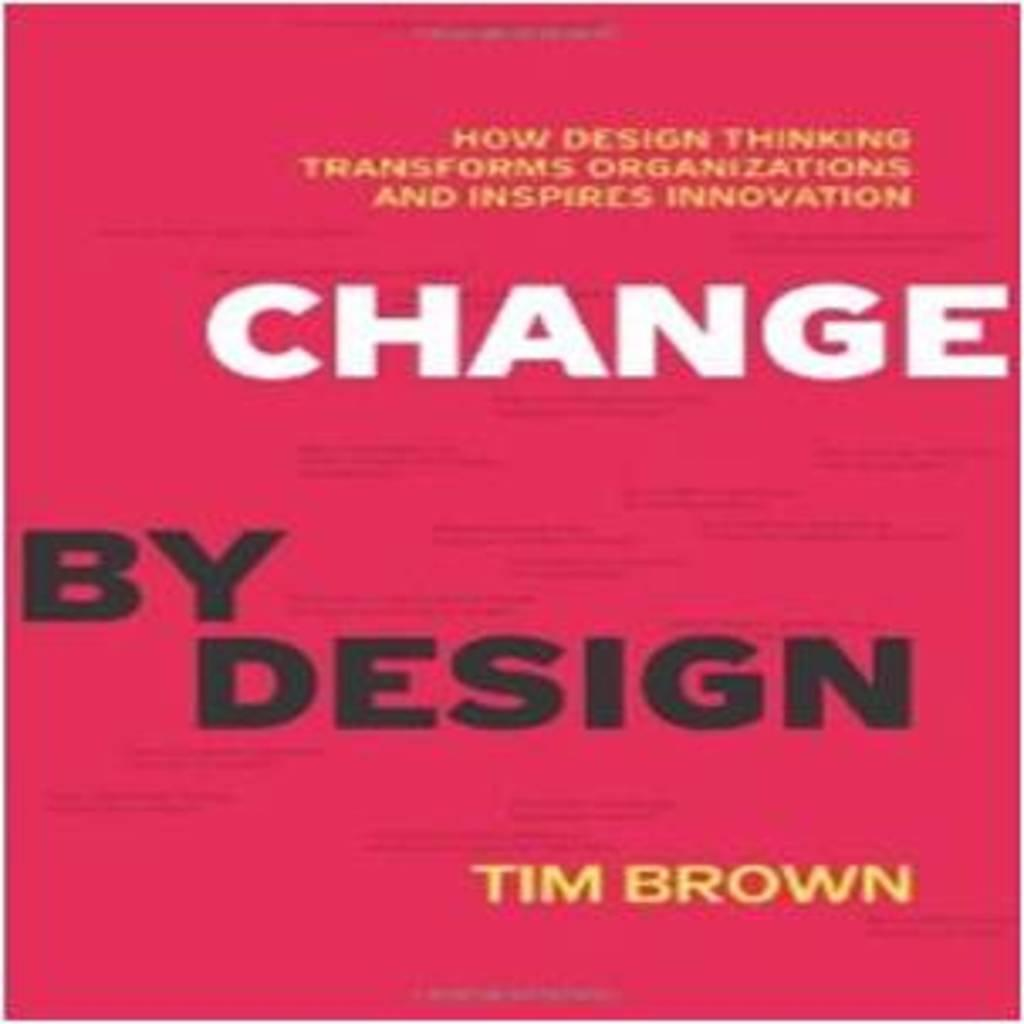Provide a one-sentence caption for the provided image. The cover of a book titled Change by Design is shown. 